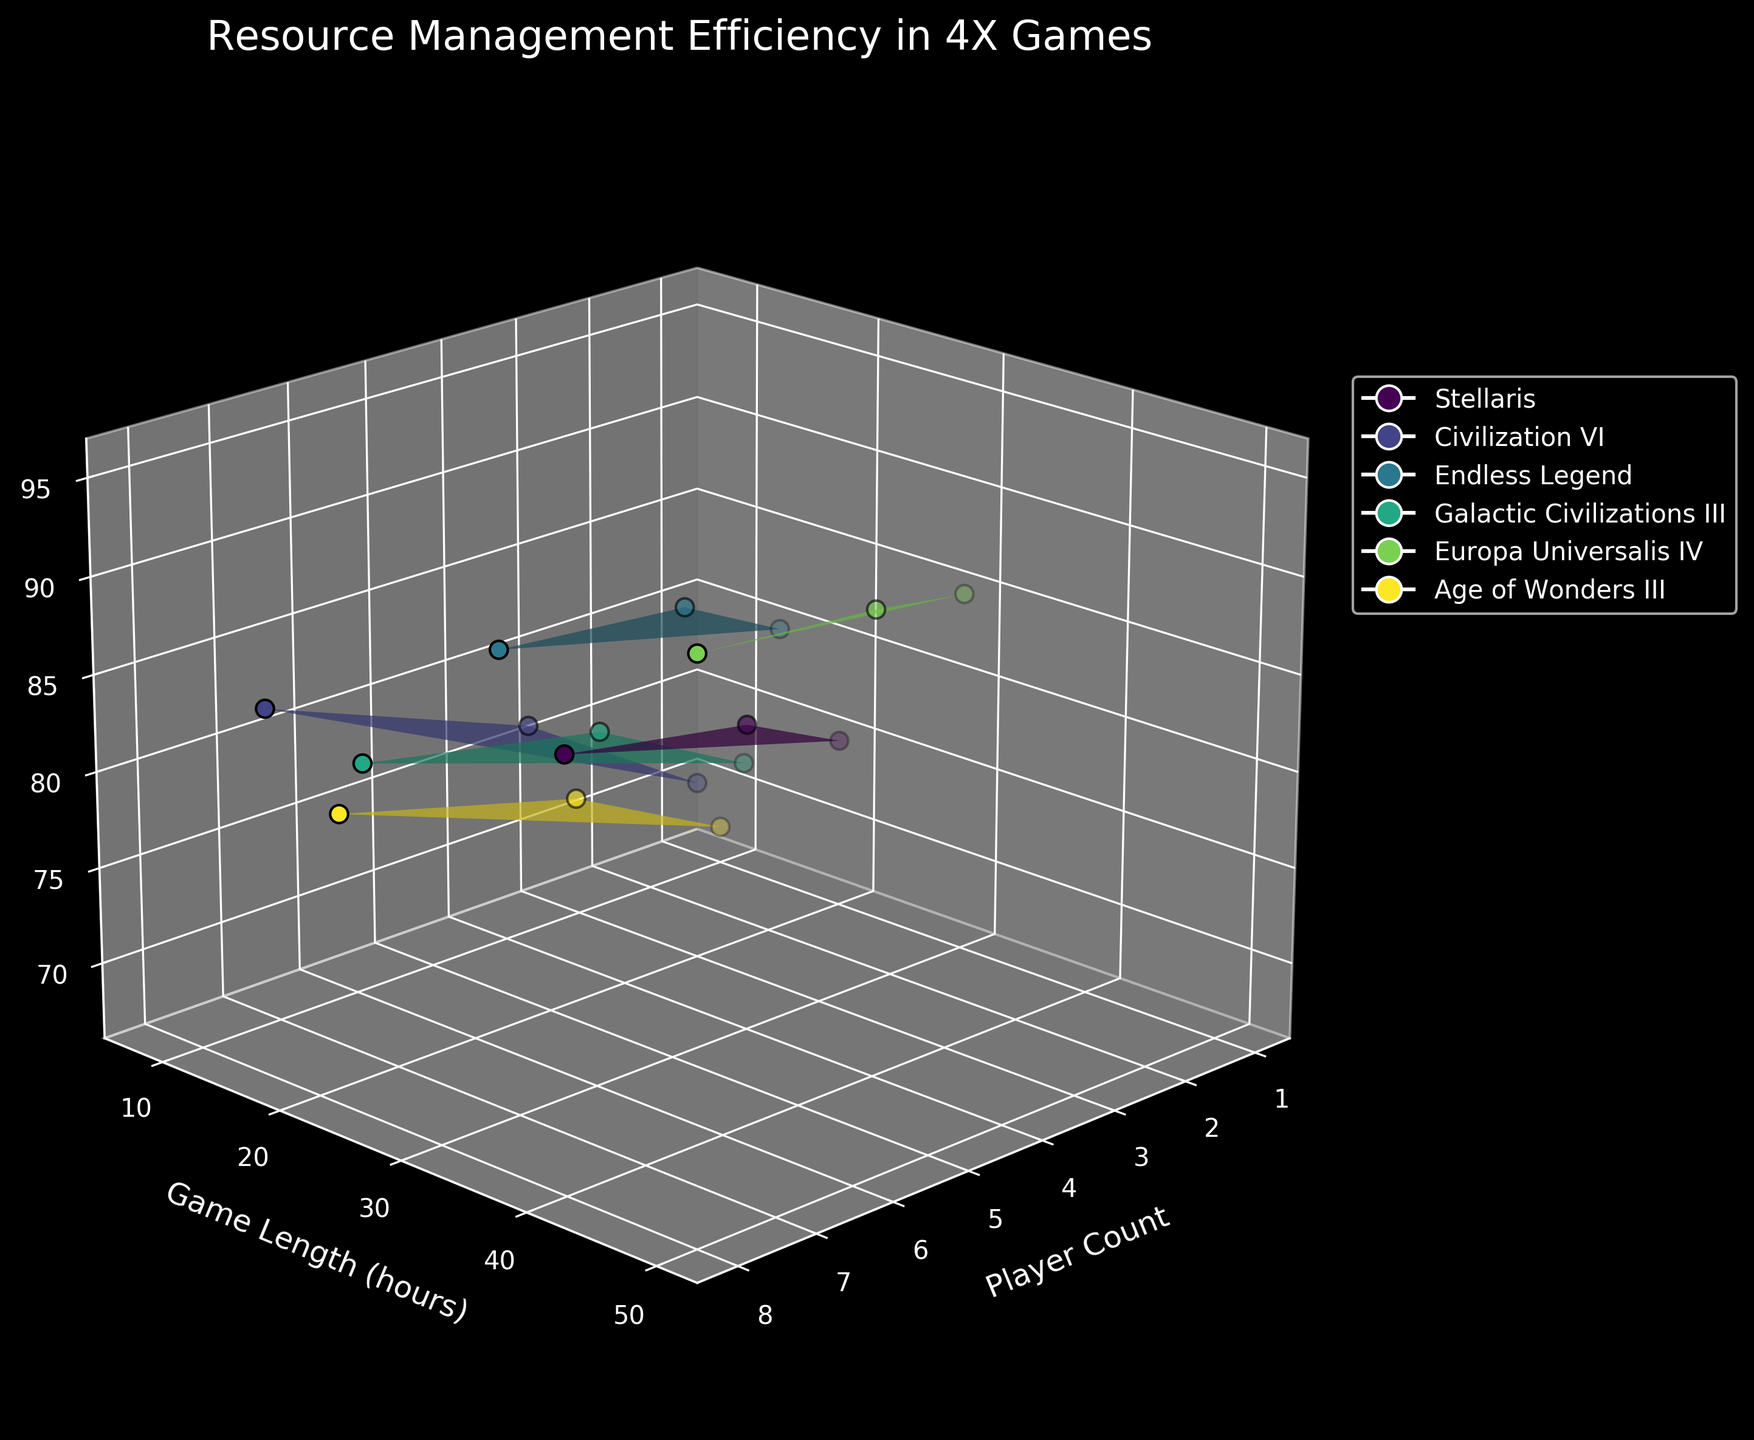How many games have their data plotted in the figure? The number of unique identifiers (i.e., games) determines how many games are plotted. Observing the plot's legend, we see that each game is represented by a different color. We count these unique colors or names to find the number of games.
Answer: 6 What is the title of the figure? The title of a plot is usually displayed prominently above the plotting area and summarizes what the plot represents. Looking at this area of the figure, we can read the title directly.
Answer: Resource Management Efficiency in 4X Games Which game has the highest Resource Management Efficiency? The highest point on the 'Resource Management Efficiency' axis signifies the maximum efficiency. By tracing this highest point down to the corresponding game name, we're able to identify the game.
Answer: Europa Universalis IV What is the Resource Management Efficiency for Civilization VI when played with 4 players? First, locate Civilization VI, identified by a specific color. Next, find the plot point or surface section corresponding to 4 players. Finally, read off the Resource Management Efficiency value at that point.
Answer: 78 Which game shows the greatest improvement in Resource Management Efficiency as the Player Count increases from 1 to 8? To find this, analyze the difference in Resource Management Efficiency between 1 player and 8 players for each game. The game with the largest increase represents the game with the greatest improvement.
Answer: Europa Universalis IV For which game does Resource Management Efficiency peak at the shortest game length? Identify the lowest point on the 'Game Length (hours)' axis where Resource Management Efficiency is maximized across all surfaces. Then trace this value back to the corresponding game.
Answer: Civilization VI Which two games have similar Resource Management Efficiency values when played by 8 players? Look for the data points or surface segments that correspond to 8 players for each game. Compare the Resource Management Efficiency values visually to identify two games with closest efficiency values.
Answer: Civilization VI and Galactic Civilizations III How does Resource Management Efficiency change for Galactic Civilizations III between 1 and 4 players? Locate the points/surfaces where Galactic Civilizations III is plotted for 1 and 4 players. By examining the 'Resource Management Efficiency' values, determine how these values change.
Answer: It increases from 72 to 79 If I want to play a game maximizing Resource Management Efficiency with 4 players and around 30 hours of game length, which game should I choose? Find the games plotted with 4 players and locate those near the 30-hour mark. Compare their Resource Management Efficiency values and choose the game with the highest value.
Answer: Stellaris 